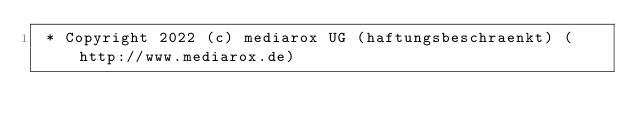<code> <loc_0><loc_0><loc_500><loc_500><_XML_> * Copyright 2022 (c) mediarox UG (haftungsbeschraenkt) (http://www.mediarox.de)</code> 